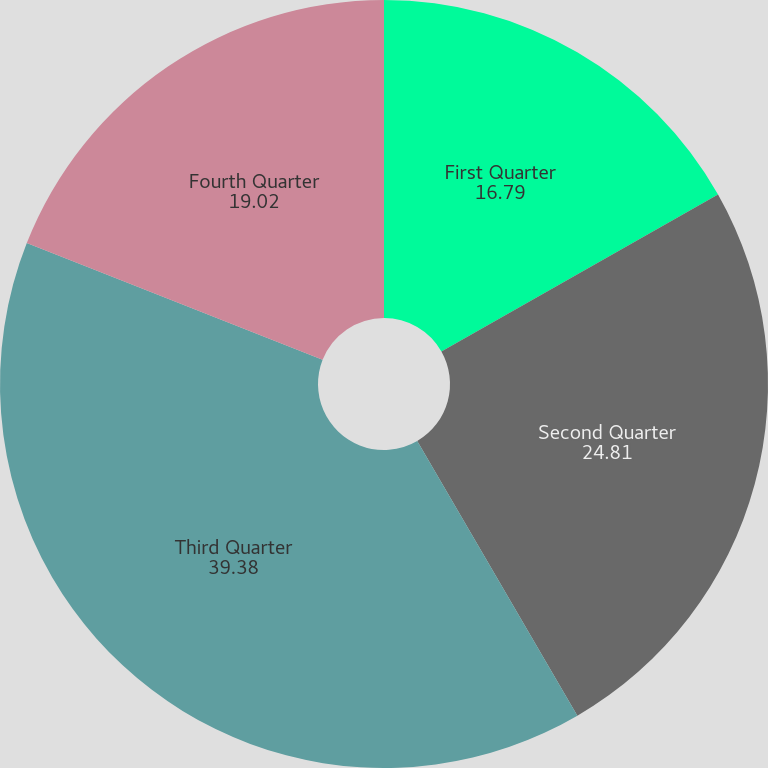Convert chart to OTSL. <chart><loc_0><loc_0><loc_500><loc_500><pie_chart><fcel>First Quarter<fcel>Second Quarter<fcel>Third Quarter<fcel>Fourth Quarter<nl><fcel>16.79%<fcel>24.81%<fcel>39.38%<fcel>19.02%<nl></chart> 